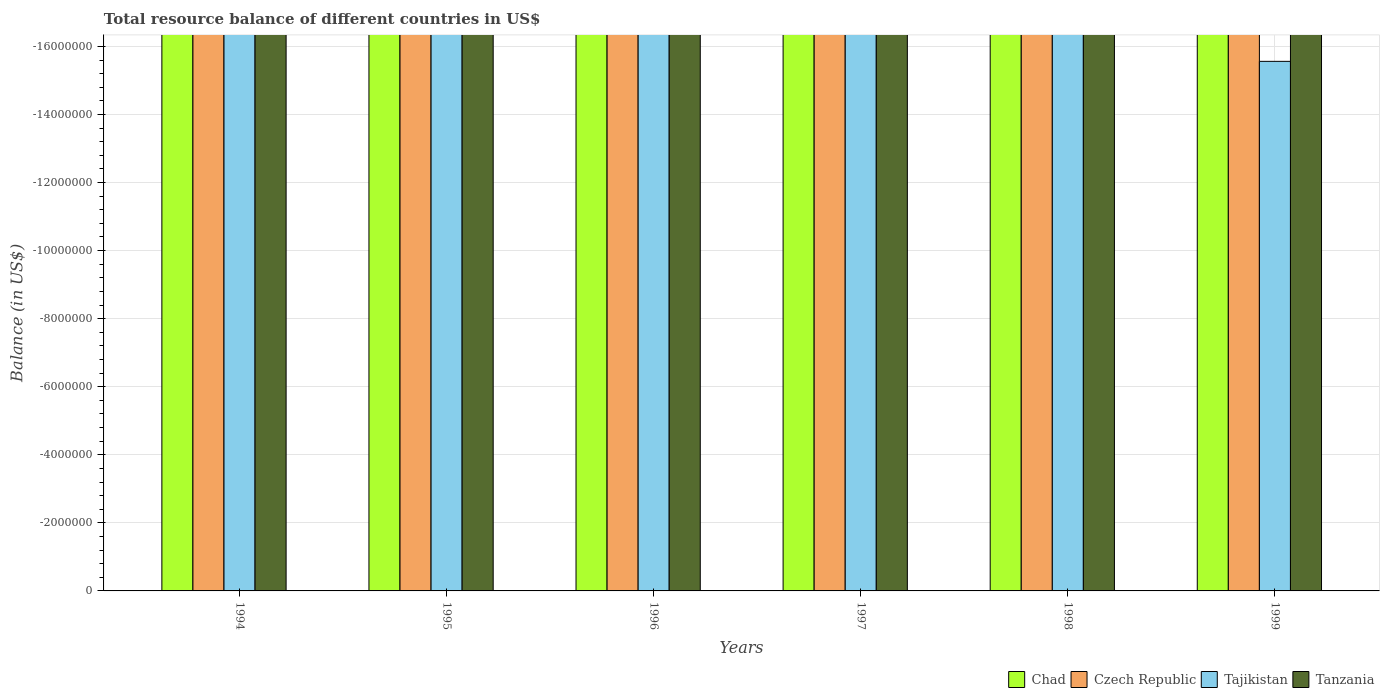Are the number of bars on each tick of the X-axis equal?
Provide a succinct answer. Yes. How many bars are there on the 6th tick from the right?
Ensure brevity in your answer.  0. What is the label of the 3rd group of bars from the left?
Your answer should be very brief. 1996. What is the difference between the total resource balance in Tanzania in 1998 and the total resource balance in Czech Republic in 1996?
Keep it short and to the point. 0. What is the average total resource balance in Tajikistan per year?
Provide a succinct answer. 0. Is it the case that in every year, the sum of the total resource balance in Chad and total resource balance in Tajikistan is greater than the sum of total resource balance in Tanzania and total resource balance in Czech Republic?
Keep it short and to the point. No. How many bars are there?
Make the answer very short. 0. Are all the bars in the graph horizontal?
Your answer should be very brief. No. How many years are there in the graph?
Ensure brevity in your answer.  6. What is the difference between two consecutive major ticks on the Y-axis?
Provide a succinct answer. 2.00e+06. Does the graph contain any zero values?
Your answer should be compact. Yes. How many legend labels are there?
Your answer should be very brief. 4. How are the legend labels stacked?
Ensure brevity in your answer.  Horizontal. What is the title of the graph?
Give a very brief answer. Total resource balance of different countries in US$. What is the label or title of the X-axis?
Provide a succinct answer. Years. What is the label or title of the Y-axis?
Your answer should be very brief. Balance (in US$). What is the Balance (in US$) in Chad in 1994?
Make the answer very short. 0. What is the Balance (in US$) in Chad in 1995?
Provide a succinct answer. 0. What is the Balance (in US$) in Czech Republic in 1995?
Provide a short and direct response. 0. What is the Balance (in US$) of Tajikistan in 1995?
Your response must be concise. 0. What is the Balance (in US$) of Tanzania in 1996?
Make the answer very short. 0. What is the Balance (in US$) of Czech Republic in 1997?
Provide a short and direct response. 0. What is the Balance (in US$) in Tajikistan in 1997?
Your answer should be very brief. 0. What is the Balance (in US$) in Chad in 1998?
Your answer should be compact. 0. What is the Balance (in US$) in Czech Republic in 1998?
Provide a short and direct response. 0. What is the Balance (in US$) in Tajikistan in 1998?
Provide a short and direct response. 0. What is the Balance (in US$) in Tanzania in 1998?
Provide a short and direct response. 0. What is the Balance (in US$) in Chad in 1999?
Your response must be concise. 0. What is the Balance (in US$) in Czech Republic in 1999?
Your response must be concise. 0. What is the average Balance (in US$) of Chad per year?
Provide a succinct answer. 0. What is the average Balance (in US$) in Czech Republic per year?
Your answer should be compact. 0. 